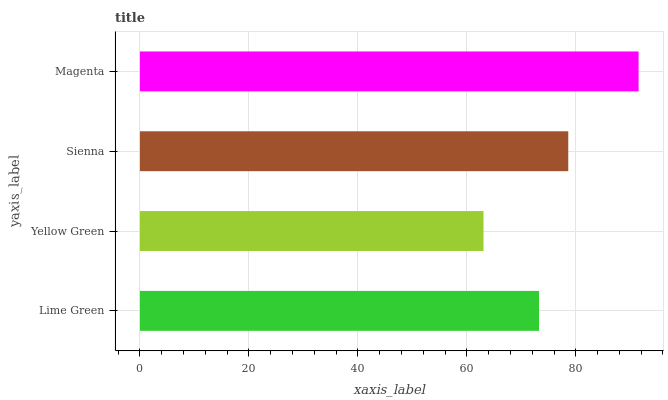Is Yellow Green the minimum?
Answer yes or no. Yes. Is Magenta the maximum?
Answer yes or no. Yes. Is Sienna the minimum?
Answer yes or no. No. Is Sienna the maximum?
Answer yes or no. No. Is Sienna greater than Yellow Green?
Answer yes or no. Yes. Is Yellow Green less than Sienna?
Answer yes or no. Yes. Is Yellow Green greater than Sienna?
Answer yes or no. No. Is Sienna less than Yellow Green?
Answer yes or no. No. Is Sienna the high median?
Answer yes or no. Yes. Is Lime Green the low median?
Answer yes or no. Yes. Is Magenta the high median?
Answer yes or no. No. Is Magenta the low median?
Answer yes or no. No. 